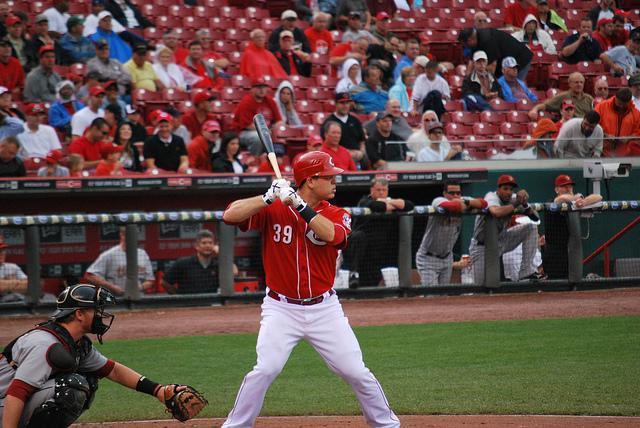How many people are there?
Give a very brief answer. 6. How many buses are behind a street sign?
Give a very brief answer. 0. 